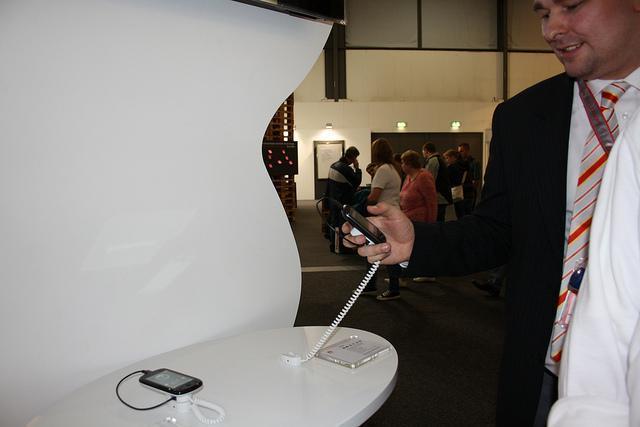How many people can be seen?
Give a very brief answer. 4. 